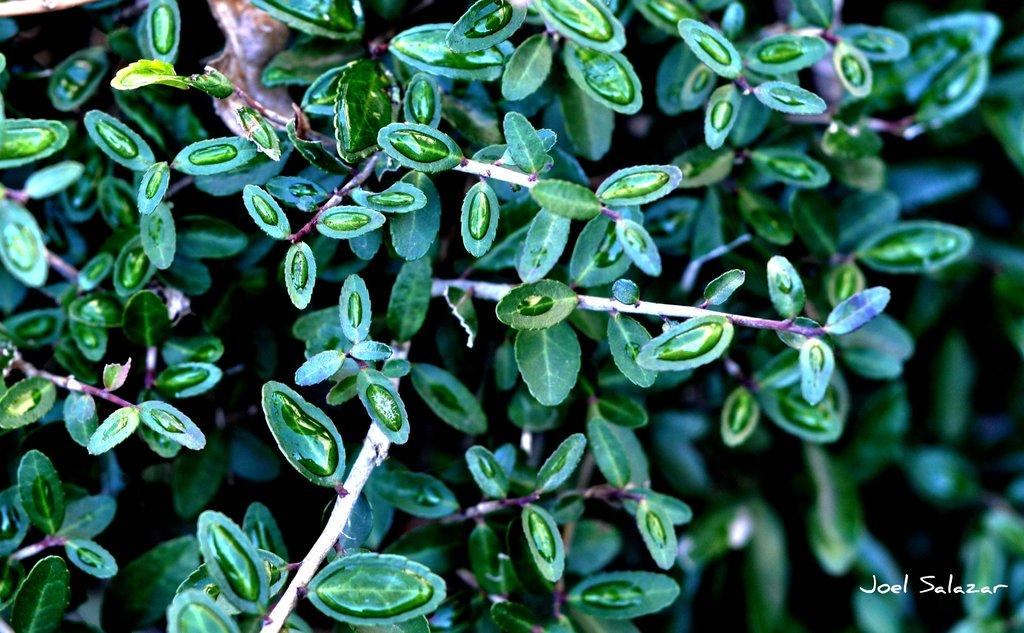What is the main subject of the image? There is a plant in the image. Can you describe the appearance of the plant? The plant has water droplets on it. How would you describe the background of the image? The background of the image is slightly blurred. Is there any text present in the image? Yes, there is edited text in the image. How many baskets are hanging from the plant in the image? There are no baskets present in the image; it only features a plant with water droplets. What advice does the mother give about the plant in the image? There is no mother or advice present in the image; it only contains a plant, water droplets, a blurred background, and edited text. 